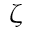Convert formula to latex. <formula><loc_0><loc_0><loc_500><loc_500>\zeta</formula> 